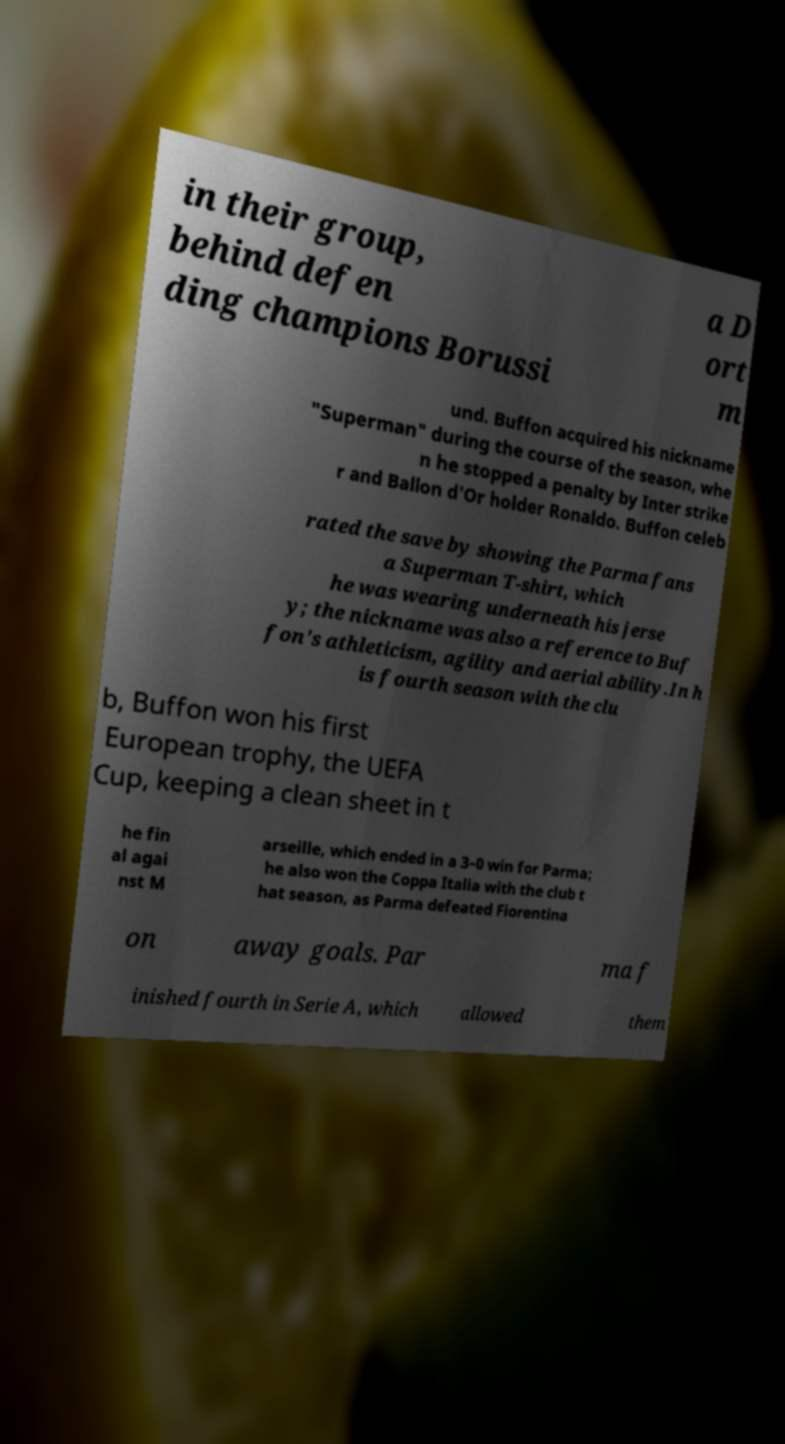Please read and relay the text visible in this image. What does it say? in their group, behind defen ding champions Borussi a D ort m und. Buffon acquired his nickname "Superman" during the course of the season, whe n he stopped a penalty by Inter strike r and Ballon d'Or holder Ronaldo. Buffon celeb rated the save by showing the Parma fans a Superman T-shirt, which he was wearing underneath his jerse y; the nickname was also a reference to Buf fon's athleticism, agility and aerial ability.In h is fourth season with the clu b, Buffon won his first European trophy, the UEFA Cup, keeping a clean sheet in t he fin al agai nst M arseille, which ended in a 3–0 win for Parma; he also won the Coppa Italia with the club t hat season, as Parma defeated Fiorentina on away goals. Par ma f inished fourth in Serie A, which allowed them 